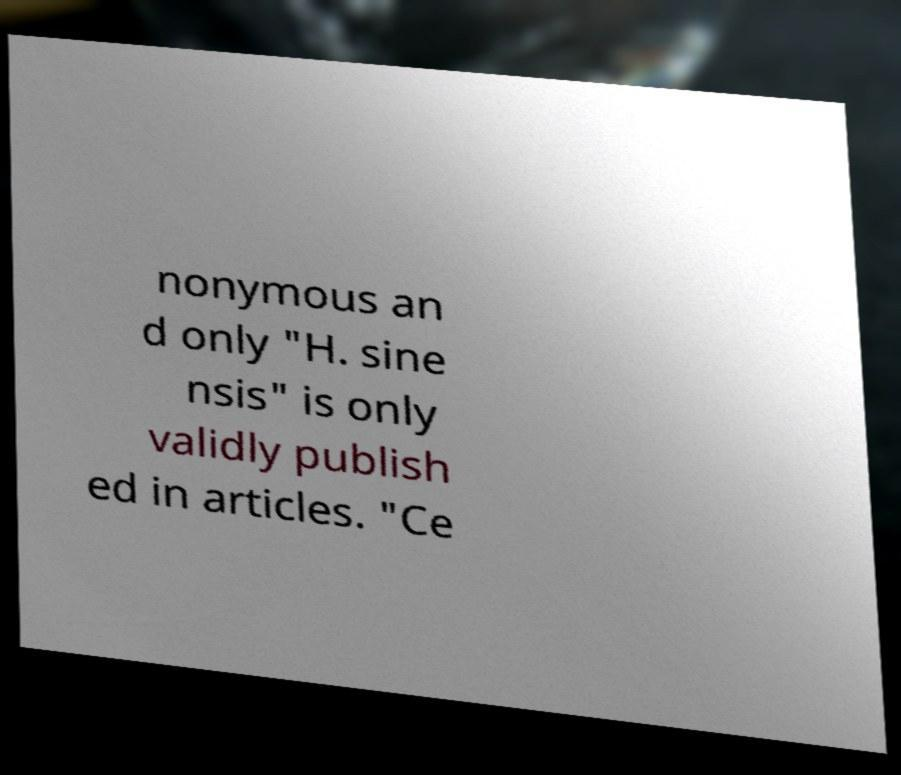Can you accurately transcribe the text from the provided image for me? nonymous an d only "H. sine nsis" is only validly publish ed in articles. "Ce 